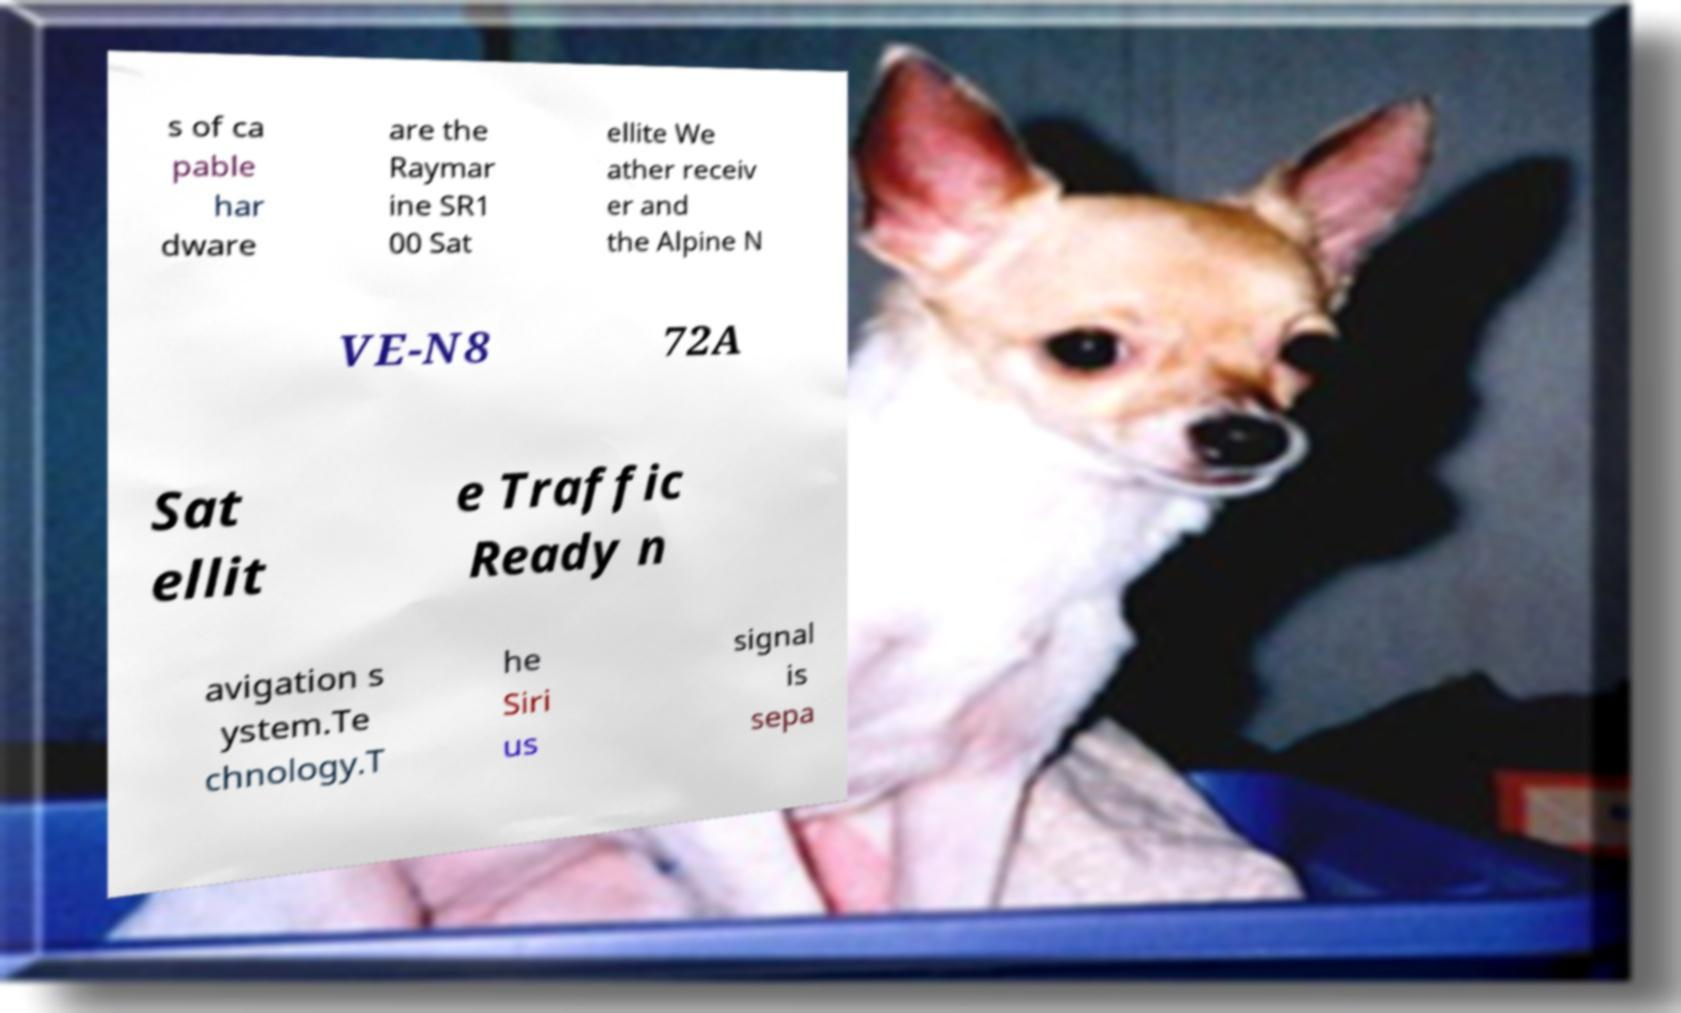Could you assist in decoding the text presented in this image and type it out clearly? s of ca pable har dware are the Raymar ine SR1 00 Sat ellite We ather receiv er and the Alpine N VE-N8 72A Sat ellit e Traffic Ready n avigation s ystem.Te chnology.T he Siri us signal is sepa 